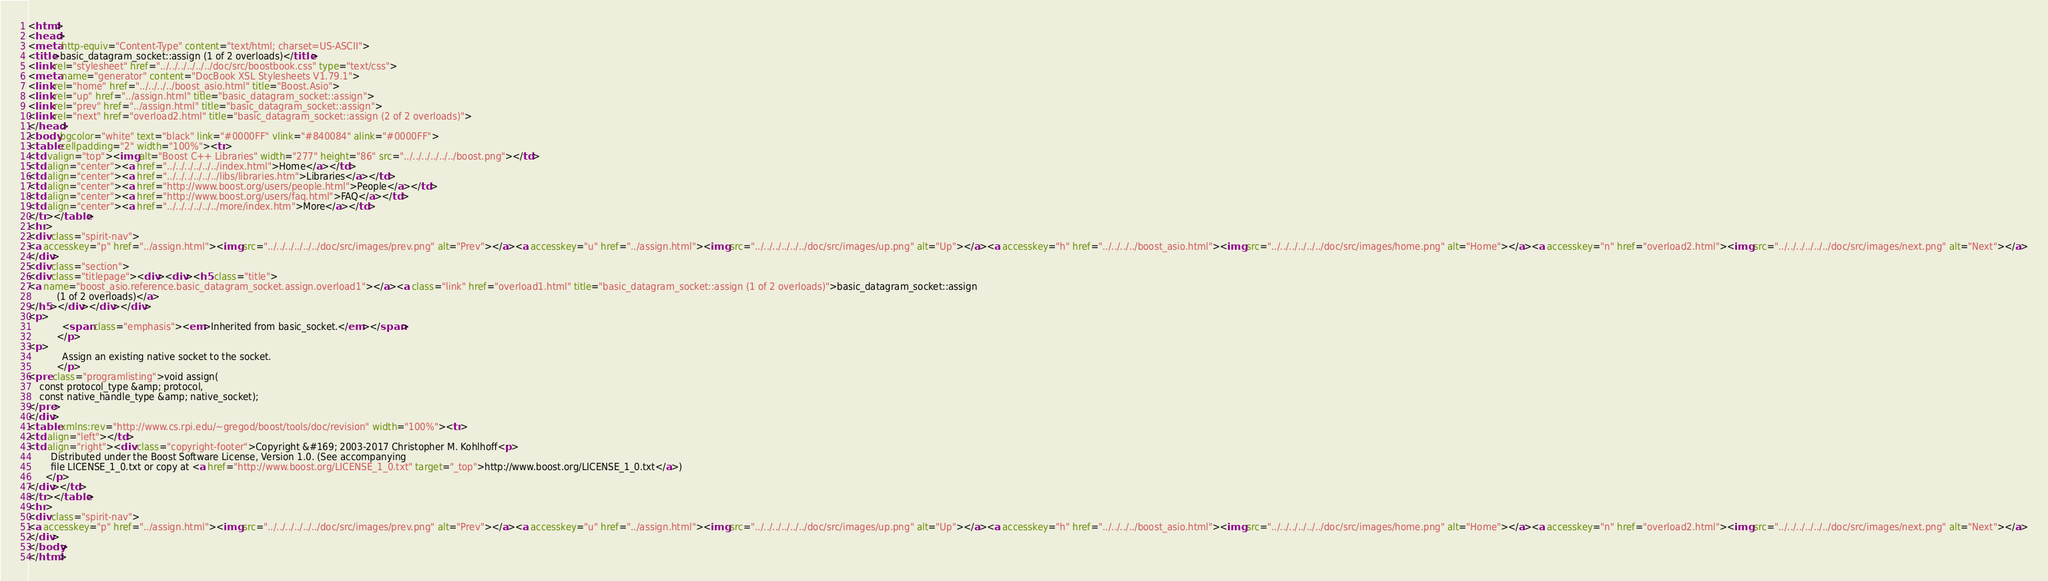Convert code to text. <code><loc_0><loc_0><loc_500><loc_500><_HTML_><html>
<head>
<meta http-equiv="Content-Type" content="text/html; charset=US-ASCII">
<title>basic_datagram_socket::assign (1 of 2 overloads)</title>
<link rel="stylesheet" href="../../../../../../doc/src/boostbook.css" type="text/css">
<meta name="generator" content="DocBook XSL Stylesheets V1.79.1">
<link rel="home" href="../../../../boost_asio.html" title="Boost.Asio">
<link rel="up" href="../assign.html" title="basic_datagram_socket::assign">
<link rel="prev" href="../assign.html" title="basic_datagram_socket::assign">
<link rel="next" href="overload2.html" title="basic_datagram_socket::assign (2 of 2 overloads)">
</head>
<body bgcolor="white" text="black" link="#0000FF" vlink="#840084" alink="#0000FF">
<table cellpadding="2" width="100%"><tr>
<td valign="top"><img alt="Boost C++ Libraries" width="277" height="86" src="../../../../../../boost.png"></td>
<td align="center"><a href="../../../../../../index.html">Home</a></td>
<td align="center"><a href="../../../../../../libs/libraries.htm">Libraries</a></td>
<td align="center"><a href="http://www.boost.org/users/people.html">People</a></td>
<td align="center"><a href="http://www.boost.org/users/faq.html">FAQ</a></td>
<td align="center"><a href="../../../../../../more/index.htm">More</a></td>
</tr></table>
<hr>
<div class="spirit-nav">
<a accesskey="p" href="../assign.html"><img src="../../../../../../doc/src/images/prev.png" alt="Prev"></a><a accesskey="u" href="../assign.html"><img src="../../../../../../doc/src/images/up.png" alt="Up"></a><a accesskey="h" href="../../../../boost_asio.html"><img src="../../../../../../doc/src/images/home.png" alt="Home"></a><a accesskey="n" href="overload2.html"><img src="../../../../../../doc/src/images/next.png" alt="Next"></a>
</div>
<div class="section">
<div class="titlepage"><div><div><h5 class="title">
<a name="boost_asio.reference.basic_datagram_socket.assign.overload1"></a><a class="link" href="overload1.html" title="basic_datagram_socket::assign (1 of 2 overloads)">basic_datagram_socket::assign
          (1 of 2 overloads)</a>
</h5></div></div></div>
<p>
            <span class="emphasis"><em>Inherited from basic_socket.</em></span>
          </p>
<p>
            Assign an existing native socket to the socket.
          </p>
<pre class="programlisting">void assign(
    const protocol_type &amp; protocol,
    const native_handle_type &amp; native_socket);
</pre>
</div>
<table xmlns:rev="http://www.cs.rpi.edu/~gregod/boost/tools/doc/revision" width="100%"><tr>
<td align="left"></td>
<td align="right"><div class="copyright-footer">Copyright &#169; 2003-2017 Christopher M. Kohlhoff<p>
        Distributed under the Boost Software License, Version 1.0. (See accompanying
        file LICENSE_1_0.txt or copy at <a href="http://www.boost.org/LICENSE_1_0.txt" target="_top">http://www.boost.org/LICENSE_1_0.txt</a>)
      </p>
</div></td>
</tr></table>
<hr>
<div class="spirit-nav">
<a accesskey="p" href="../assign.html"><img src="../../../../../../doc/src/images/prev.png" alt="Prev"></a><a accesskey="u" href="../assign.html"><img src="../../../../../../doc/src/images/up.png" alt="Up"></a><a accesskey="h" href="../../../../boost_asio.html"><img src="../../../../../../doc/src/images/home.png" alt="Home"></a><a accesskey="n" href="overload2.html"><img src="../../../../../../doc/src/images/next.png" alt="Next"></a>
</div>
</body>
</html>
</code> 